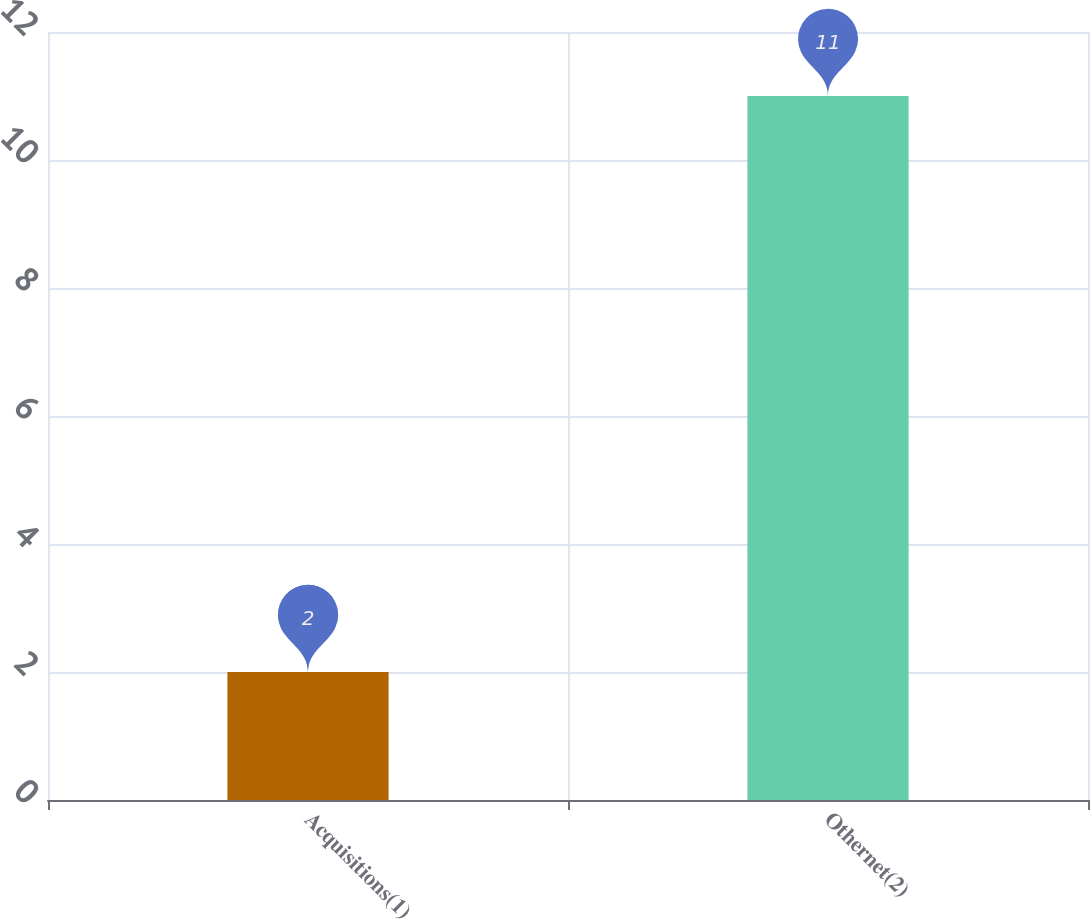<chart> <loc_0><loc_0><loc_500><loc_500><bar_chart><fcel>Acquisitions(1)<fcel>Othernet(2)<nl><fcel>2<fcel>11<nl></chart> 